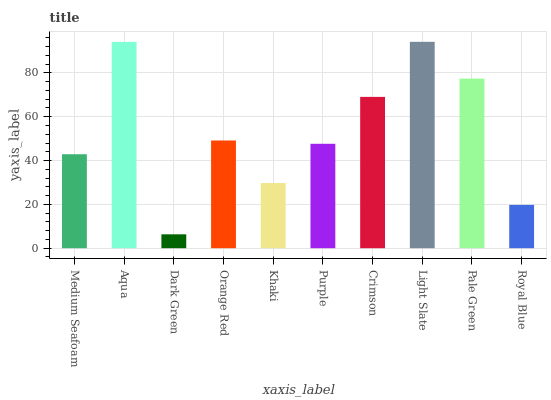Is Dark Green the minimum?
Answer yes or no. Yes. Is Light Slate the maximum?
Answer yes or no. Yes. Is Aqua the minimum?
Answer yes or no. No. Is Aqua the maximum?
Answer yes or no. No. Is Aqua greater than Medium Seafoam?
Answer yes or no. Yes. Is Medium Seafoam less than Aqua?
Answer yes or no. Yes. Is Medium Seafoam greater than Aqua?
Answer yes or no. No. Is Aqua less than Medium Seafoam?
Answer yes or no. No. Is Orange Red the high median?
Answer yes or no. Yes. Is Purple the low median?
Answer yes or no. Yes. Is Khaki the high median?
Answer yes or no. No. Is Orange Red the low median?
Answer yes or no. No. 